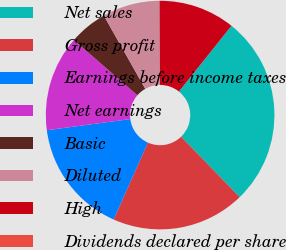Convert chart. <chart><loc_0><loc_0><loc_500><loc_500><pie_chart><fcel>Net sales<fcel>Gross profit<fcel>Earnings before income taxes<fcel>Net earnings<fcel>Basic<fcel>Diluted<fcel>High<fcel>Dividends declared per share<nl><fcel>27.02%<fcel>18.92%<fcel>16.22%<fcel>13.51%<fcel>5.41%<fcel>8.11%<fcel>10.81%<fcel>0.0%<nl></chart> 